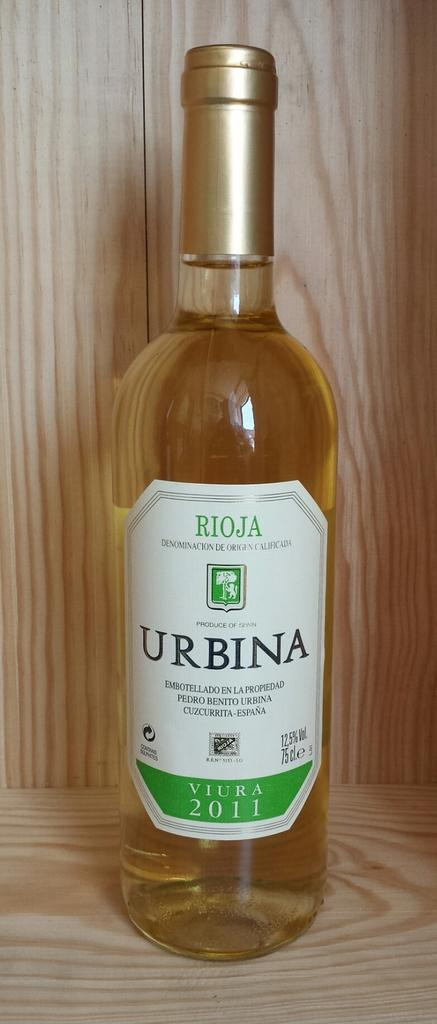What object is present in the image with a golden color lid? There is a bottle in the image with a golden color lid. Where is the bottle placed in the image? The bottle is kept in a wooden rack in the image. What can be seen on the wooden rack besides the bottle? A sticker is pasted on the wooden rack in the image. What is written on the sticker? The word 'URBINA' is written on the sticker in the image. What type of cart is used to serve breakfast in the image? There is no cart or breakfast present in the image; it only features a bottle, a wooden rack, and a sticker. How many cattle are visible in the image? There are no cattle present in the image. 